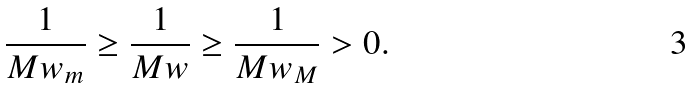<formula> <loc_0><loc_0><loc_500><loc_500>\frac { 1 } { M w _ { m } } \geq \frac { 1 } { M w } \geq \frac { 1 } { M w _ { M } } > 0 .</formula> 